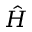<formula> <loc_0><loc_0><loc_500><loc_500>\hat { H }</formula> 